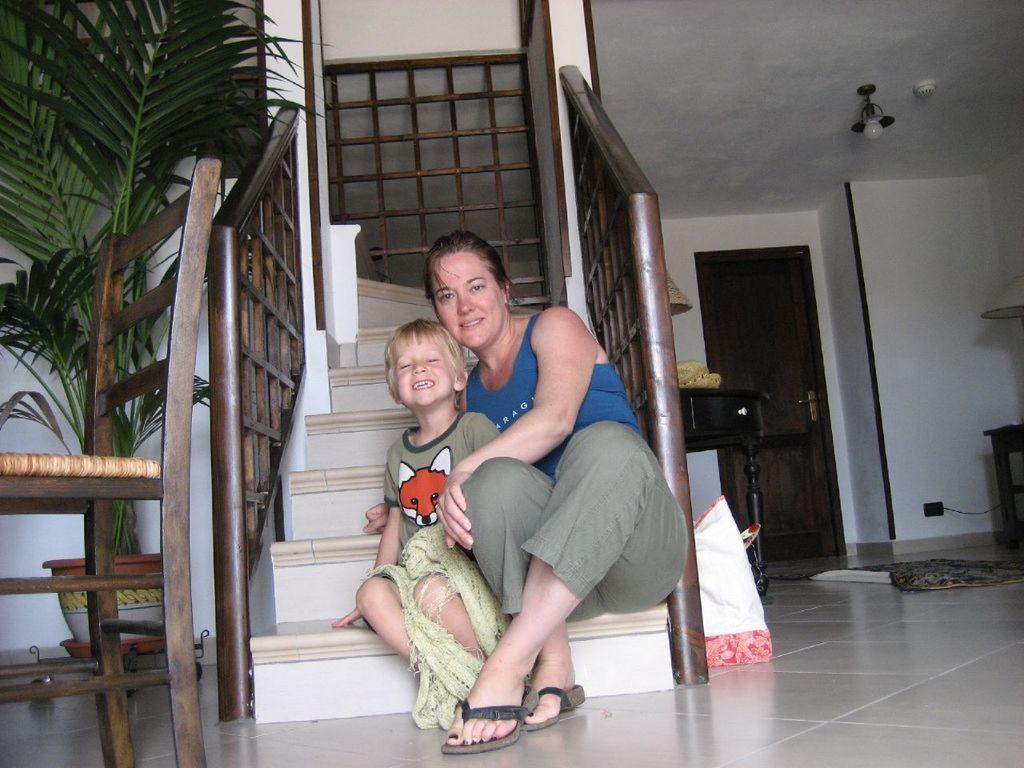Could you give a brief overview of what you see in this image? This is an inside view. In the middle of the image a woman and a boy are sitting on the stairs, smiling and giving pose for the picture. On the both sides of the stairs I can see the railings. On the right side there is a door to the wall and also I can see two tables on the floor. On the left side there is a chair and I can see a house plant. 